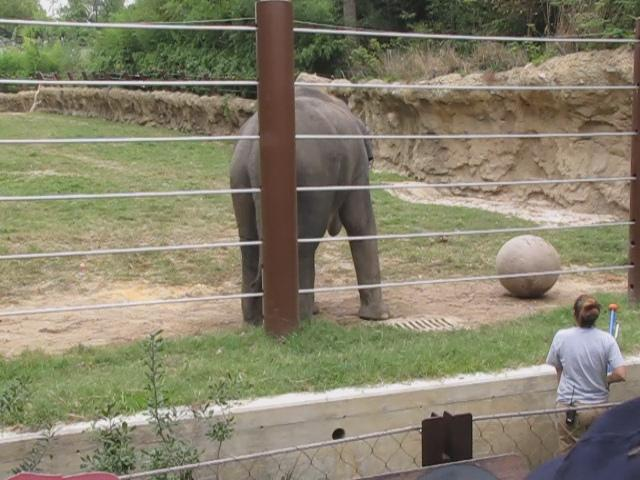How will she tell her supervisor about the welfare of the animal?

Choices:
A) walkie talkie
B) flare
C) shouting
D) text message walkie talkie 